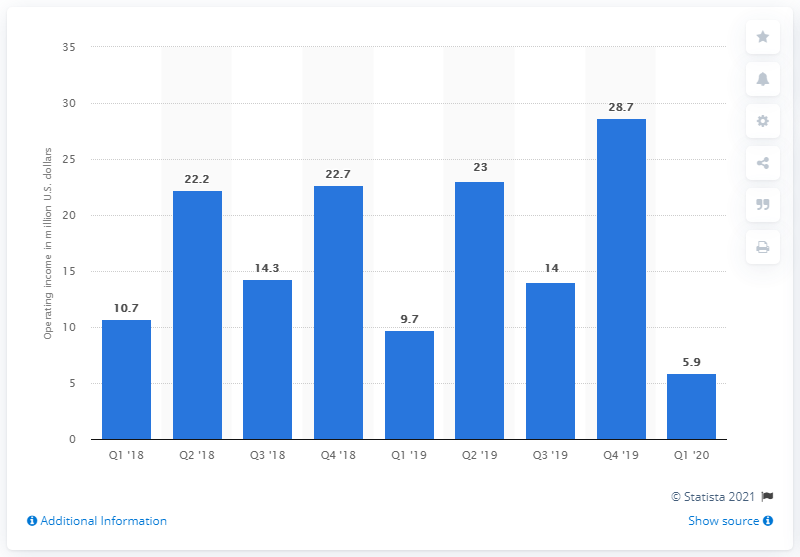Point out several critical features in this image. During the last reported period, Rakuten Rewards generated an operating income of 5.9.. According to the given information, the sum of the operating income of Rakuten Rewards during the Q1 of 2018 to Q1 of 2020 was approximately 151.2 million US dollars. Rakuten Rewards had the highest operating income during the fourth quarter of 2019, among all quarters between 2018 and 2020, with a value of millions of U.S. dollars. Rakuten Rewards' operating income in the previous period was 28.7 billion yen. 